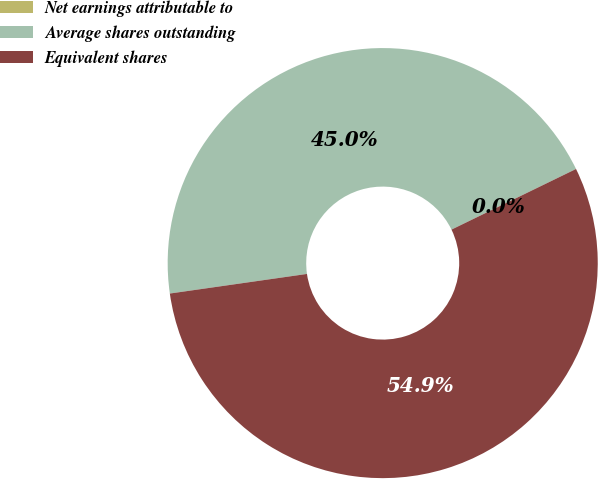<chart> <loc_0><loc_0><loc_500><loc_500><pie_chart><fcel>Net earnings attributable to<fcel>Average shares outstanding<fcel>Equivalent shares<nl><fcel>0.0%<fcel>45.05%<fcel>54.95%<nl></chart> 